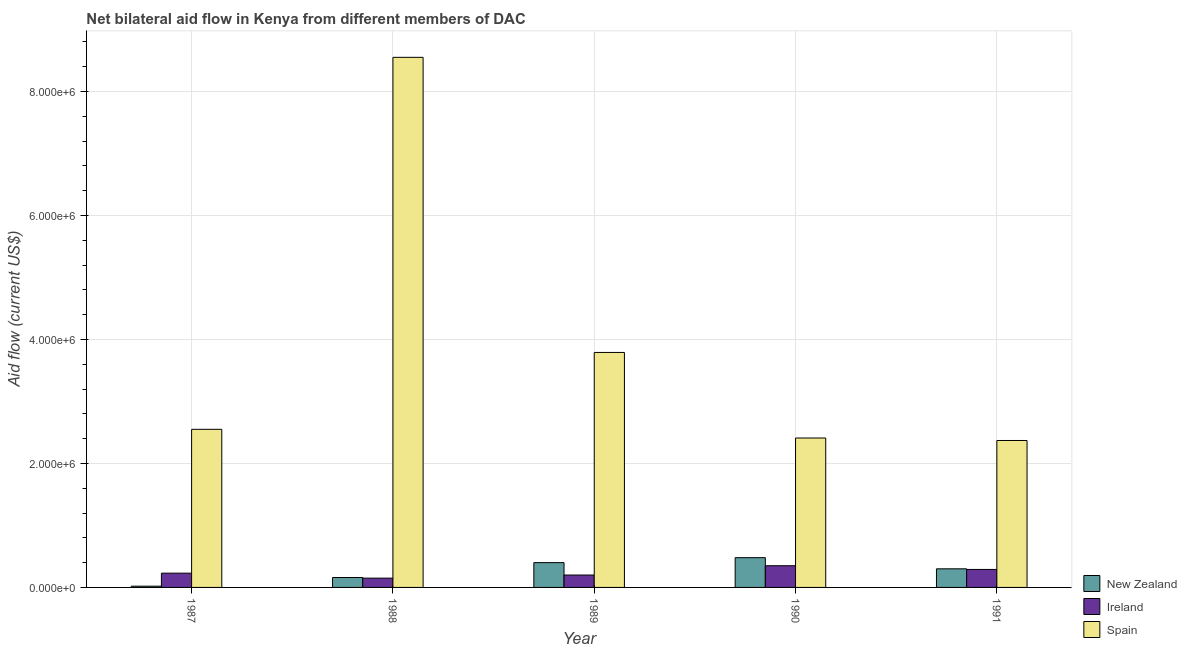How many bars are there on the 3rd tick from the right?
Provide a short and direct response. 3. What is the label of the 2nd group of bars from the left?
Your response must be concise. 1988. What is the amount of aid provided by ireland in 1989?
Offer a terse response. 2.00e+05. Across all years, what is the maximum amount of aid provided by spain?
Offer a terse response. 8.55e+06. Across all years, what is the minimum amount of aid provided by ireland?
Offer a very short reply. 1.50e+05. In which year was the amount of aid provided by spain maximum?
Your answer should be very brief. 1988. In which year was the amount of aid provided by ireland minimum?
Your answer should be compact. 1988. What is the total amount of aid provided by ireland in the graph?
Give a very brief answer. 1.22e+06. What is the difference between the amount of aid provided by ireland in 1987 and that in 1988?
Offer a very short reply. 8.00e+04. What is the difference between the amount of aid provided by ireland in 1989 and the amount of aid provided by new zealand in 1988?
Keep it short and to the point. 5.00e+04. What is the average amount of aid provided by ireland per year?
Make the answer very short. 2.44e+05. In the year 1990, what is the difference between the amount of aid provided by spain and amount of aid provided by new zealand?
Make the answer very short. 0. In how many years, is the amount of aid provided by new zealand greater than 2000000 US$?
Your answer should be compact. 0. What is the ratio of the amount of aid provided by new zealand in 1988 to that in 1989?
Keep it short and to the point. 0.4. Is the amount of aid provided by ireland in 1988 less than that in 1990?
Provide a short and direct response. Yes. Is the difference between the amount of aid provided by ireland in 1988 and 1989 greater than the difference between the amount of aid provided by new zealand in 1988 and 1989?
Ensure brevity in your answer.  No. What is the difference between the highest and the second highest amount of aid provided by spain?
Your answer should be compact. 4.76e+06. What is the difference between the highest and the lowest amount of aid provided by spain?
Provide a short and direct response. 6.18e+06. In how many years, is the amount of aid provided by ireland greater than the average amount of aid provided by ireland taken over all years?
Keep it short and to the point. 2. Is the sum of the amount of aid provided by spain in 1987 and 1990 greater than the maximum amount of aid provided by new zealand across all years?
Provide a short and direct response. No. What does the 1st bar from the left in 1991 represents?
Keep it short and to the point. New Zealand. What does the 3rd bar from the right in 1989 represents?
Your response must be concise. New Zealand. Is it the case that in every year, the sum of the amount of aid provided by new zealand and amount of aid provided by ireland is greater than the amount of aid provided by spain?
Offer a very short reply. No. Are all the bars in the graph horizontal?
Make the answer very short. No. How many years are there in the graph?
Your response must be concise. 5. Does the graph contain any zero values?
Keep it short and to the point. No. How many legend labels are there?
Make the answer very short. 3. How are the legend labels stacked?
Offer a very short reply. Vertical. What is the title of the graph?
Ensure brevity in your answer.  Net bilateral aid flow in Kenya from different members of DAC. Does "Primary education" appear as one of the legend labels in the graph?
Offer a terse response. No. What is the label or title of the X-axis?
Offer a terse response. Year. What is the label or title of the Y-axis?
Offer a terse response. Aid flow (current US$). What is the Aid flow (current US$) in Ireland in 1987?
Keep it short and to the point. 2.30e+05. What is the Aid flow (current US$) in Spain in 1987?
Make the answer very short. 2.55e+06. What is the Aid flow (current US$) in New Zealand in 1988?
Your answer should be compact. 1.60e+05. What is the Aid flow (current US$) of Ireland in 1988?
Your answer should be compact. 1.50e+05. What is the Aid flow (current US$) of Spain in 1988?
Offer a terse response. 8.55e+06. What is the Aid flow (current US$) in Spain in 1989?
Provide a short and direct response. 3.79e+06. What is the Aid flow (current US$) of New Zealand in 1990?
Offer a terse response. 4.80e+05. What is the Aid flow (current US$) in Spain in 1990?
Your answer should be very brief. 2.41e+06. What is the Aid flow (current US$) in New Zealand in 1991?
Make the answer very short. 3.00e+05. What is the Aid flow (current US$) in Spain in 1991?
Offer a terse response. 2.37e+06. Across all years, what is the maximum Aid flow (current US$) in New Zealand?
Keep it short and to the point. 4.80e+05. Across all years, what is the maximum Aid flow (current US$) in Ireland?
Ensure brevity in your answer.  3.50e+05. Across all years, what is the maximum Aid flow (current US$) of Spain?
Your response must be concise. 8.55e+06. Across all years, what is the minimum Aid flow (current US$) in Spain?
Offer a terse response. 2.37e+06. What is the total Aid flow (current US$) in New Zealand in the graph?
Ensure brevity in your answer.  1.36e+06. What is the total Aid flow (current US$) in Ireland in the graph?
Provide a succinct answer. 1.22e+06. What is the total Aid flow (current US$) of Spain in the graph?
Give a very brief answer. 1.97e+07. What is the difference between the Aid flow (current US$) in New Zealand in 1987 and that in 1988?
Offer a terse response. -1.40e+05. What is the difference between the Aid flow (current US$) in Spain in 1987 and that in 1988?
Your answer should be very brief. -6.00e+06. What is the difference between the Aid flow (current US$) of New Zealand in 1987 and that in 1989?
Give a very brief answer. -3.80e+05. What is the difference between the Aid flow (current US$) in Ireland in 1987 and that in 1989?
Offer a very short reply. 3.00e+04. What is the difference between the Aid flow (current US$) of Spain in 1987 and that in 1989?
Your answer should be very brief. -1.24e+06. What is the difference between the Aid flow (current US$) in New Zealand in 1987 and that in 1990?
Ensure brevity in your answer.  -4.60e+05. What is the difference between the Aid flow (current US$) of New Zealand in 1987 and that in 1991?
Give a very brief answer. -2.80e+05. What is the difference between the Aid flow (current US$) of Spain in 1987 and that in 1991?
Your answer should be compact. 1.80e+05. What is the difference between the Aid flow (current US$) in New Zealand in 1988 and that in 1989?
Your answer should be very brief. -2.40e+05. What is the difference between the Aid flow (current US$) of Ireland in 1988 and that in 1989?
Keep it short and to the point. -5.00e+04. What is the difference between the Aid flow (current US$) in Spain in 1988 and that in 1989?
Your answer should be very brief. 4.76e+06. What is the difference between the Aid flow (current US$) of New Zealand in 1988 and that in 1990?
Keep it short and to the point. -3.20e+05. What is the difference between the Aid flow (current US$) of Spain in 1988 and that in 1990?
Provide a succinct answer. 6.14e+06. What is the difference between the Aid flow (current US$) of Ireland in 1988 and that in 1991?
Give a very brief answer. -1.40e+05. What is the difference between the Aid flow (current US$) of Spain in 1988 and that in 1991?
Offer a very short reply. 6.18e+06. What is the difference between the Aid flow (current US$) in Ireland in 1989 and that in 1990?
Keep it short and to the point. -1.50e+05. What is the difference between the Aid flow (current US$) of Spain in 1989 and that in 1990?
Ensure brevity in your answer.  1.38e+06. What is the difference between the Aid flow (current US$) of New Zealand in 1989 and that in 1991?
Your response must be concise. 1.00e+05. What is the difference between the Aid flow (current US$) of Ireland in 1989 and that in 1991?
Provide a succinct answer. -9.00e+04. What is the difference between the Aid flow (current US$) in Spain in 1989 and that in 1991?
Provide a short and direct response. 1.42e+06. What is the difference between the Aid flow (current US$) of New Zealand in 1990 and that in 1991?
Offer a terse response. 1.80e+05. What is the difference between the Aid flow (current US$) in New Zealand in 1987 and the Aid flow (current US$) in Ireland in 1988?
Give a very brief answer. -1.30e+05. What is the difference between the Aid flow (current US$) of New Zealand in 1987 and the Aid flow (current US$) of Spain in 1988?
Your response must be concise. -8.53e+06. What is the difference between the Aid flow (current US$) of Ireland in 1987 and the Aid flow (current US$) of Spain in 1988?
Offer a terse response. -8.32e+06. What is the difference between the Aid flow (current US$) in New Zealand in 1987 and the Aid flow (current US$) in Ireland in 1989?
Your answer should be compact. -1.80e+05. What is the difference between the Aid flow (current US$) of New Zealand in 1987 and the Aid flow (current US$) of Spain in 1989?
Provide a succinct answer. -3.77e+06. What is the difference between the Aid flow (current US$) in Ireland in 1987 and the Aid flow (current US$) in Spain in 1989?
Provide a succinct answer. -3.56e+06. What is the difference between the Aid flow (current US$) of New Zealand in 1987 and the Aid flow (current US$) of Ireland in 1990?
Make the answer very short. -3.30e+05. What is the difference between the Aid flow (current US$) in New Zealand in 1987 and the Aid flow (current US$) in Spain in 1990?
Offer a very short reply. -2.39e+06. What is the difference between the Aid flow (current US$) in Ireland in 1987 and the Aid flow (current US$) in Spain in 1990?
Provide a succinct answer. -2.18e+06. What is the difference between the Aid flow (current US$) of New Zealand in 1987 and the Aid flow (current US$) of Ireland in 1991?
Ensure brevity in your answer.  -2.70e+05. What is the difference between the Aid flow (current US$) of New Zealand in 1987 and the Aid flow (current US$) of Spain in 1991?
Keep it short and to the point. -2.35e+06. What is the difference between the Aid flow (current US$) of Ireland in 1987 and the Aid flow (current US$) of Spain in 1991?
Keep it short and to the point. -2.14e+06. What is the difference between the Aid flow (current US$) in New Zealand in 1988 and the Aid flow (current US$) in Ireland in 1989?
Offer a very short reply. -4.00e+04. What is the difference between the Aid flow (current US$) in New Zealand in 1988 and the Aid flow (current US$) in Spain in 1989?
Make the answer very short. -3.63e+06. What is the difference between the Aid flow (current US$) in Ireland in 1988 and the Aid flow (current US$) in Spain in 1989?
Provide a succinct answer. -3.64e+06. What is the difference between the Aid flow (current US$) of New Zealand in 1988 and the Aid flow (current US$) of Spain in 1990?
Keep it short and to the point. -2.25e+06. What is the difference between the Aid flow (current US$) of Ireland in 1988 and the Aid flow (current US$) of Spain in 1990?
Your answer should be compact. -2.26e+06. What is the difference between the Aid flow (current US$) in New Zealand in 1988 and the Aid flow (current US$) in Ireland in 1991?
Offer a terse response. -1.30e+05. What is the difference between the Aid flow (current US$) in New Zealand in 1988 and the Aid flow (current US$) in Spain in 1991?
Offer a very short reply. -2.21e+06. What is the difference between the Aid flow (current US$) of Ireland in 1988 and the Aid flow (current US$) of Spain in 1991?
Provide a short and direct response. -2.22e+06. What is the difference between the Aid flow (current US$) in New Zealand in 1989 and the Aid flow (current US$) in Spain in 1990?
Offer a terse response. -2.01e+06. What is the difference between the Aid flow (current US$) of Ireland in 1989 and the Aid flow (current US$) of Spain in 1990?
Ensure brevity in your answer.  -2.21e+06. What is the difference between the Aid flow (current US$) of New Zealand in 1989 and the Aid flow (current US$) of Ireland in 1991?
Your answer should be compact. 1.10e+05. What is the difference between the Aid flow (current US$) of New Zealand in 1989 and the Aid flow (current US$) of Spain in 1991?
Keep it short and to the point. -1.97e+06. What is the difference between the Aid flow (current US$) in Ireland in 1989 and the Aid flow (current US$) in Spain in 1991?
Keep it short and to the point. -2.17e+06. What is the difference between the Aid flow (current US$) in New Zealand in 1990 and the Aid flow (current US$) in Spain in 1991?
Make the answer very short. -1.89e+06. What is the difference between the Aid flow (current US$) of Ireland in 1990 and the Aid flow (current US$) of Spain in 1991?
Your answer should be very brief. -2.02e+06. What is the average Aid flow (current US$) in New Zealand per year?
Offer a very short reply. 2.72e+05. What is the average Aid flow (current US$) in Ireland per year?
Keep it short and to the point. 2.44e+05. What is the average Aid flow (current US$) of Spain per year?
Provide a short and direct response. 3.93e+06. In the year 1987, what is the difference between the Aid flow (current US$) in New Zealand and Aid flow (current US$) in Ireland?
Your answer should be very brief. -2.10e+05. In the year 1987, what is the difference between the Aid flow (current US$) of New Zealand and Aid flow (current US$) of Spain?
Provide a succinct answer. -2.53e+06. In the year 1987, what is the difference between the Aid flow (current US$) of Ireland and Aid flow (current US$) of Spain?
Your answer should be very brief. -2.32e+06. In the year 1988, what is the difference between the Aid flow (current US$) of New Zealand and Aid flow (current US$) of Ireland?
Offer a terse response. 10000. In the year 1988, what is the difference between the Aid flow (current US$) in New Zealand and Aid flow (current US$) in Spain?
Offer a very short reply. -8.39e+06. In the year 1988, what is the difference between the Aid flow (current US$) in Ireland and Aid flow (current US$) in Spain?
Your answer should be compact. -8.40e+06. In the year 1989, what is the difference between the Aid flow (current US$) in New Zealand and Aid flow (current US$) in Spain?
Give a very brief answer. -3.39e+06. In the year 1989, what is the difference between the Aid flow (current US$) in Ireland and Aid flow (current US$) in Spain?
Your response must be concise. -3.59e+06. In the year 1990, what is the difference between the Aid flow (current US$) in New Zealand and Aid flow (current US$) in Ireland?
Offer a very short reply. 1.30e+05. In the year 1990, what is the difference between the Aid flow (current US$) in New Zealand and Aid flow (current US$) in Spain?
Ensure brevity in your answer.  -1.93e+06. In the year 1990, what is the difference between the Aid flow (current US$) in Ireland and Aid flow (current US$) in Spain?
Your answer should be very brief. -2.06e+06. In the year 1991, what is the difference between the Aid flow (current US$) in New Zealand and Aid flow (current US$) in Ireland?
Ensure brevity in your answer.  10000. In the year 1991, what is the difference between the Aid flow (current US$) of New Zealand and Aid flow (current US$) of Spain?
Your answer should be compact. -2.07e+06. In the year 1991, what is the difference between the Aid flow (current US$) of Ireland and Aid flow (current US$) of Spain?
Your response must be concise. -2.08e+06. What is the ratio of the Aid flow (current US$) in New Zealand in 1987 to that in 1988?
Your answer should be very brief. 0.12. What is the ratio of the Aid flow (current US$) of Ireland in 1987 to that in 1988?
Make the answer very short. 1.53. What is the ratio of the Aid flow (current US$) in Spain in 1987 to that in 1988?
Provide a succinct answer. 0.3. What is the ratio of the Aid flow (current US$) in Ireland in 1987 to that in 1989?
Your response must be concise. 1.15. What is the ratio of the Aid flow (current US$) in Spain in 1987 to that in 1989?
Keep it short and to the point. 0.67. What is the ratio of the Aid flow (current US$) of New Zealand in 1987 to that in 1990?
Your response must be concise. 0.04. What is the ratio of the Aid flow (current US$) of Ireland in 1987 to that in 1990?
Offer a very short reply. 0.66. What is the ratio of the Aid flow (current US$) of Spain in 1987 to that in 1990?
Your response must be concise. 1.06. What is the ratio of the Aid flow (current US$) of New Zealand in 1987 to that in 1991?
Provide a short and direct response. 0.07. What is the ratio of the Aid flow (current US$) in Ireland in 1987 to that in 1991?
Give a very brief answer. 0.79. What is the ratio of the Aid flow (current US$) of Spain in 1987 to that in 1991?
Offer a terse response. 1.08. What is the ratio of the Aid flow (current US$) in New Zealand in 1988 to that in 1989?
Offer a very short reply. 0.4. What is the ratio of the Aid flow (current US$) in Spain in 1988 to that in 1989?
Your answer should be compact. 2.26. What is the ratio of the Aid flow (current US$) in New Zealand in 1988 to that in 1990?
Offer a terse response. 0.33. What is the ratio of the Aid flow (current US$) in Ireland in 1988 to that in 1990?
Your answer should be compact. 0.43. What is the ratio of the Aid flow (current US$) in Spain in 1988 to that in 1990?
Offer a very short reply. 3.55. What is the ratio of the Aid flow (current US$) of New Zealand in 1988 to that in 1991?
Give a very brief answer. 0.53. What is the ratio of the Aid flow (current US$) of Ireland in 1988 to that in 1991?
Offer a very short reply. 0.52. What is the ratio of the Aid flow (current US$) of Spain in 1988 to that in 1991?
Provide a short and direct response. 3.61. What is the ratio of the Aid flow (current US$) in Spain in 1989 to that in 1990?
Your answer should be compact. 1.57. What is the ratio of the Aid flow (current US$) in New Zealand in 1989 to that in 1991?
Provide a succinct answer. 1.33. What is the ratio of the Aid flow (current US$) of Ireland in 1989 to that in 1991?
Give a very brief answer. 0.69. What is the ratio of the Aid flow (current US$) in Spain in 1989 to that in 1991?
Provide a short and direct response. 1.6. What is the ratio of the Aid flow (current US$) in New Zealand in 1990 to that in 1991?
Provide a short and direct response. 1.6. What is the ratio of the Aid flow (current US$) in Ireland in 1990 to that in 1991?
Provide a short and direct response. 1.21. What is the ratio of the Aid flow (current US$) of Spain in 1990 to that in 1991?
Your answer should be compact. 1.02. What is the difference between the highest and the second highest Aid flow (current US$) in Spain?
Your answer should be compact. 4.76e+06. What is the difference between the highest and the lowest Aid flow (current US$) of Spain?
Offer a very short reply. 6.18e+06. 